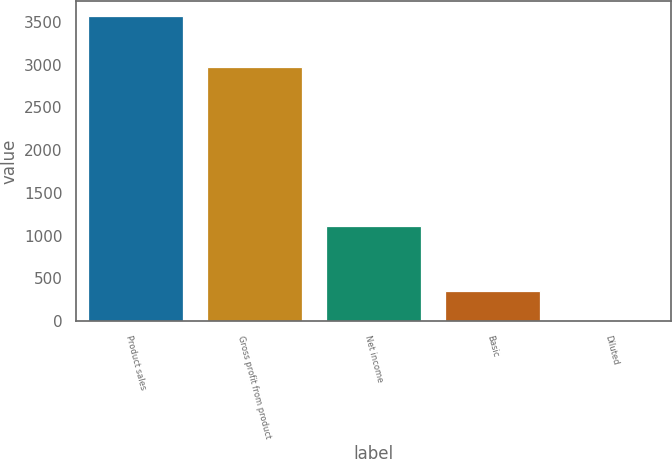Convert chart. <chart><loc_0><loc_0><loc_500><loc_500><bar_chart><fcel>Product sales<fcel>Gross profit from product<fcel>Net income<fcel>Basic<fcel>Diluted<nl><fcel>3565<fcel>2973<fcel>1111<fcel>357.35<fcel>0.94<nl></chart> 